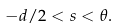Convert formula to latex. <formula><loc_0><loc_0><loc_500><loc_500>- d / 2 < s < \theta .</formula> 